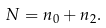<formula> <loc_0><loc_0><loc_500><loc_500>N = n _ { 0 } + n _ { 2 } .</formula> 